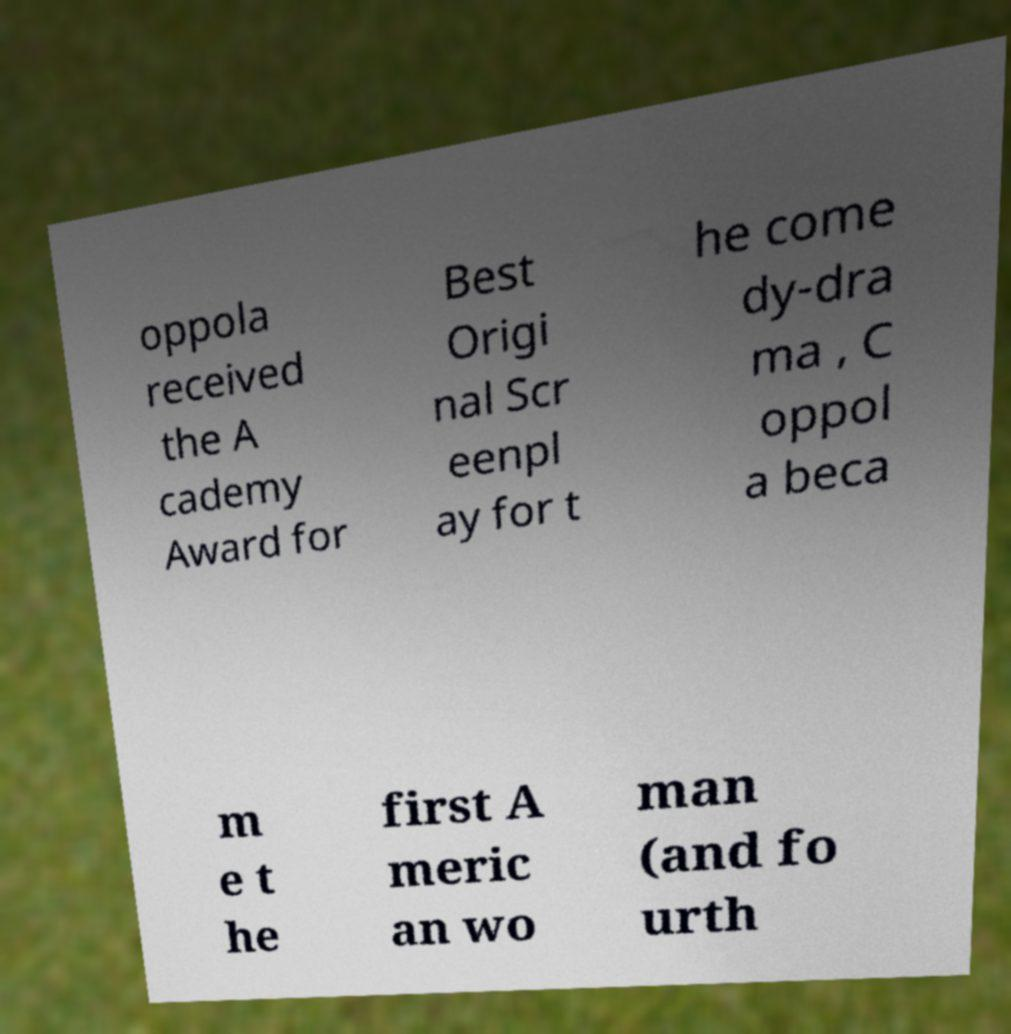Could you assist in decoding the text presented in this image and type it out clearly? oppola received the A cademy Award for Best Origi nal Scr eenpl ay for t he come dy-dra ma , C oppol a beca m e t he first A meric an wo man (and fo urth 